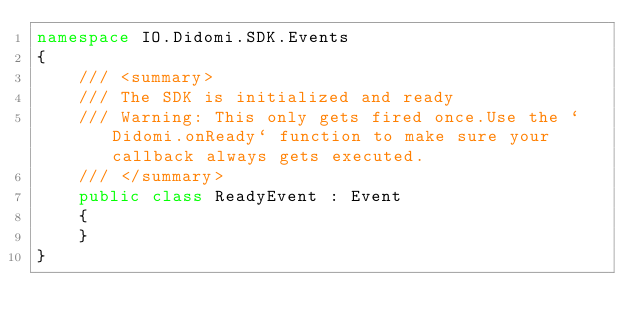Convert code to text. <code><loc_0><loc_0><loc_500><loc_500><_C#_>namespace IO.Didomi.SDK.Events
{
    /// <summary>
    /// The SDK is initialized and ready
    /// Warning: This only gets fired once.Use the `Didomi.onReady` function to make sure your callback always gets executed.
    /// </summary>
    public class ReadyEvent : Event
    {
    }
}
</code> 